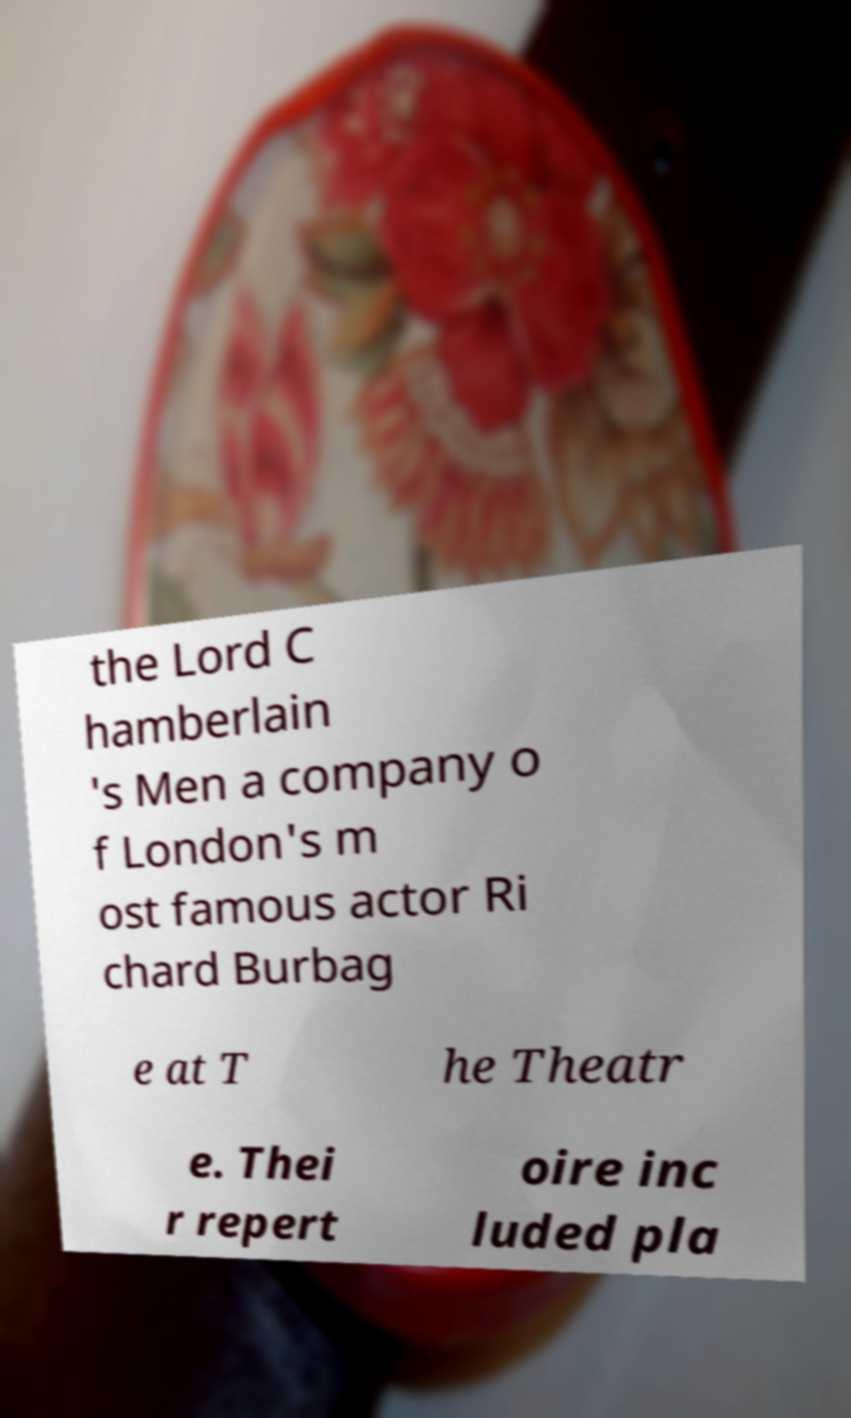Could you assist in decoding the text presented in this image and type it out clearly? the Lord C hamberlain 's Men a company o f London's m ost famous actor Ri chard Burbag e at T he Theatr e. Thei r repert oire inc luded pla 